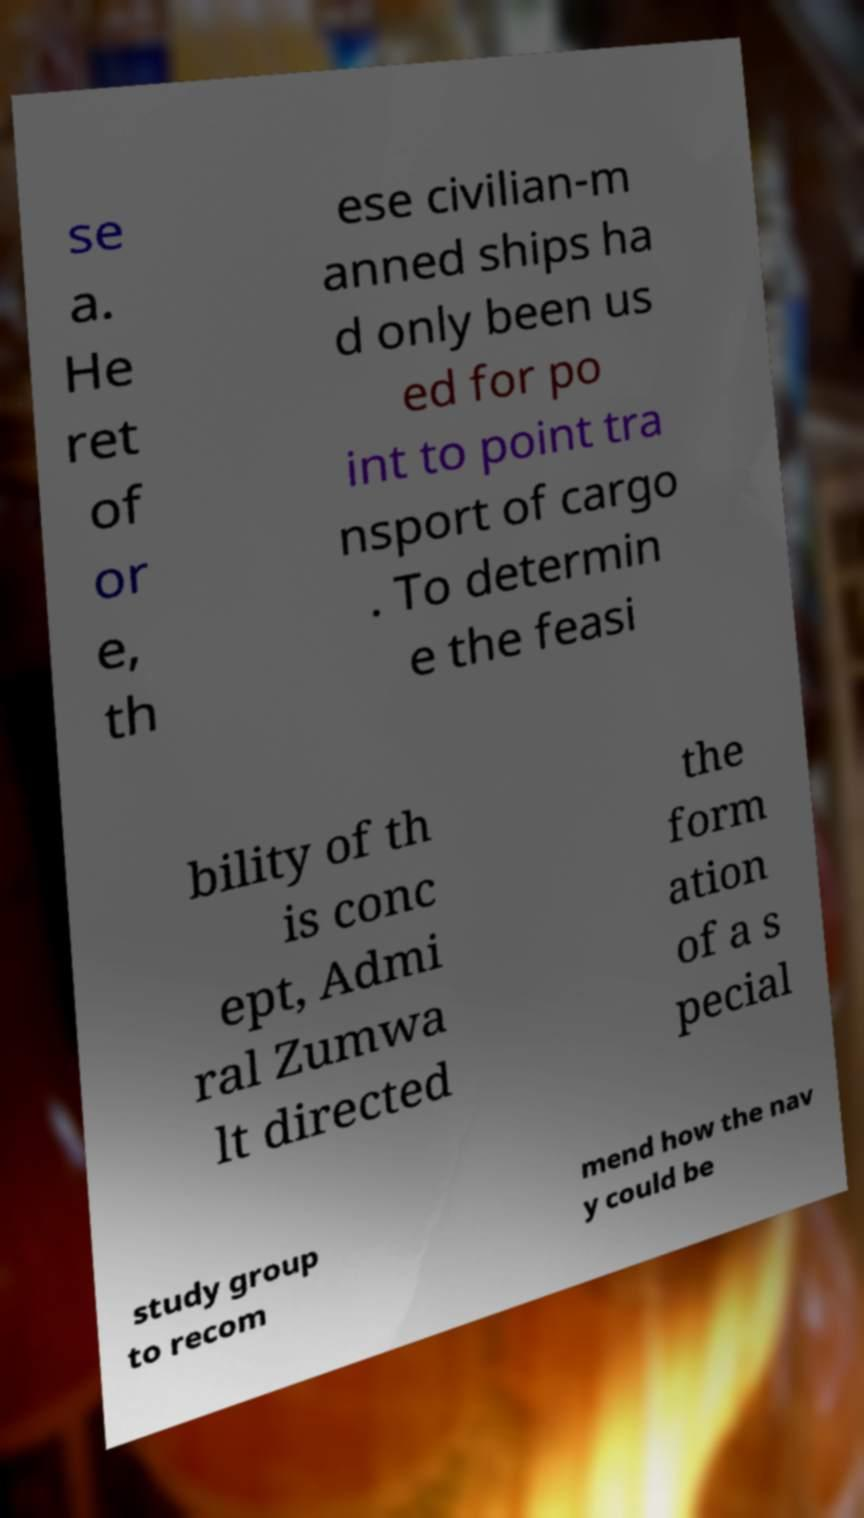For documentation purposes, I need the text within this image transcribed. Could you provide that? se a. He ret of or e, th ese civilian-m anned ships ha d only been us ed for po int to point tra nsport of cargo . To determin e the feasi bility of th is conc ept, Admi ral Zumwa lt directed the form ation of a s pecial study group to recom mend how the nav y could be 